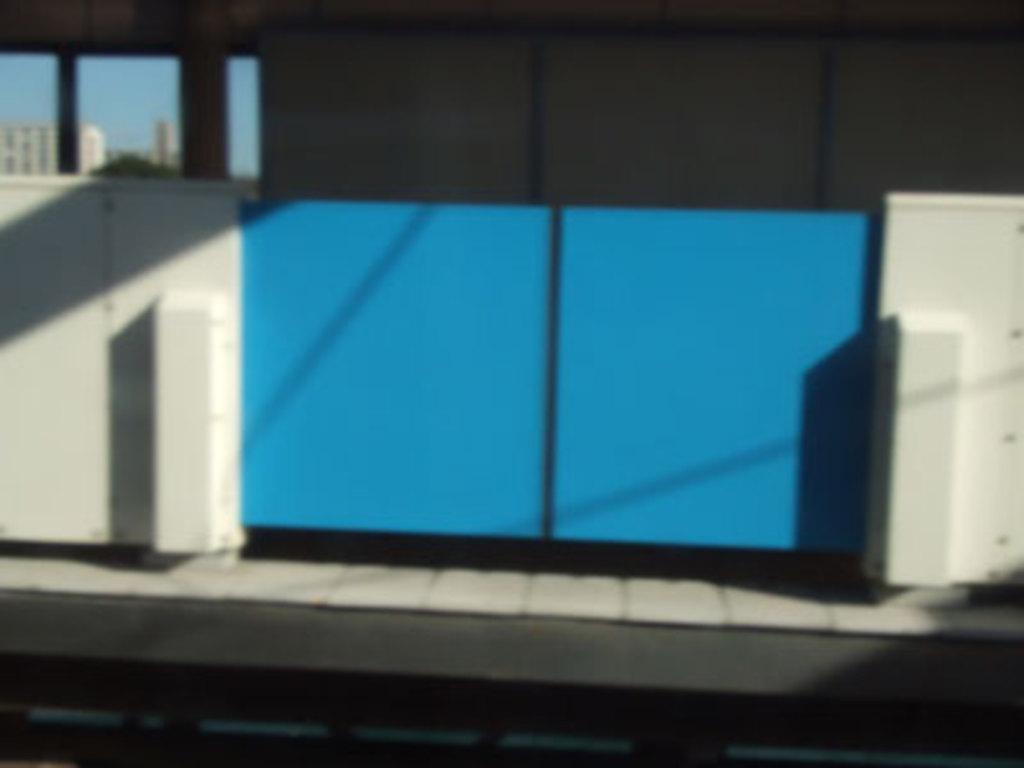What type of structures are present in the image? There are walls and a gate in the image. What can be seen behind the gate? There are poles and buildings visible behind the gate. What is visible in the background of the image? The sky is visible in the image. What type of light can be seen coming from the man's hand in the image? There is no man present in the image, and therefore no light coming from his hand. 